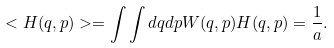<formula> <loc_0><loc_0><loc_500><loc_500>< H ( q , p ) > = \int \int d q d p W ( q , p ) H ( q , p ) = \frac { 1 } { a } .</formula> 